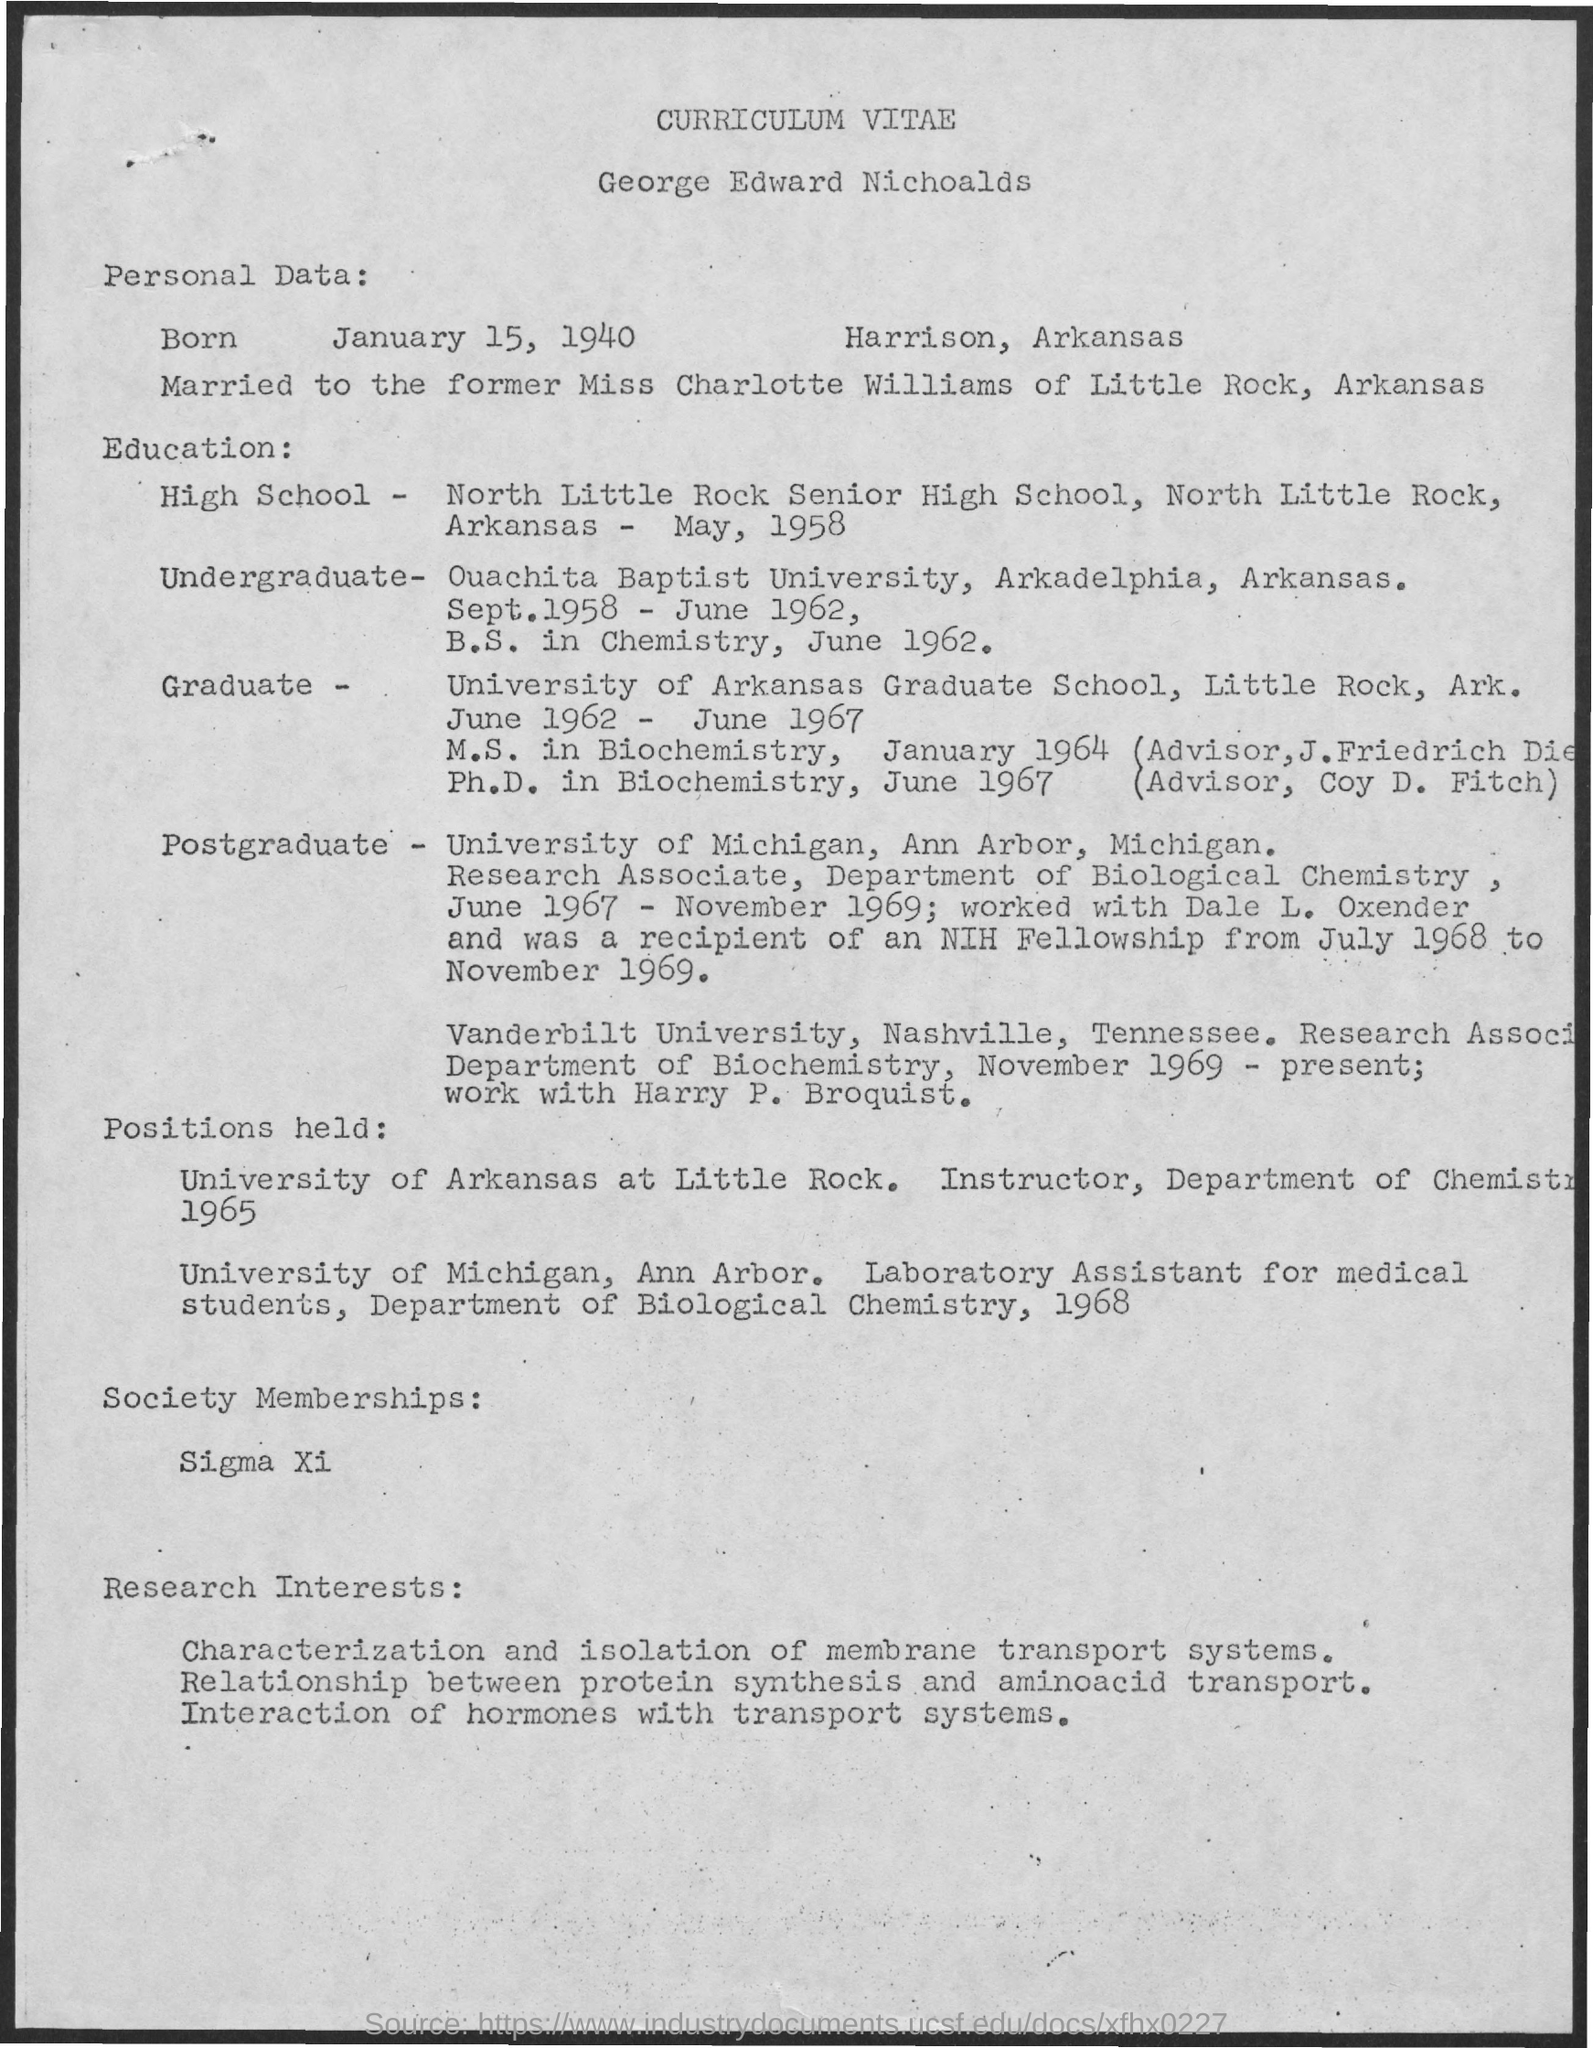Which high school George studied?
Keep it short and to the point. North little rock senior high school, North little rock, Arkansas. What is date of Birth of George?
Your response must be concise. January 15, 1940. 